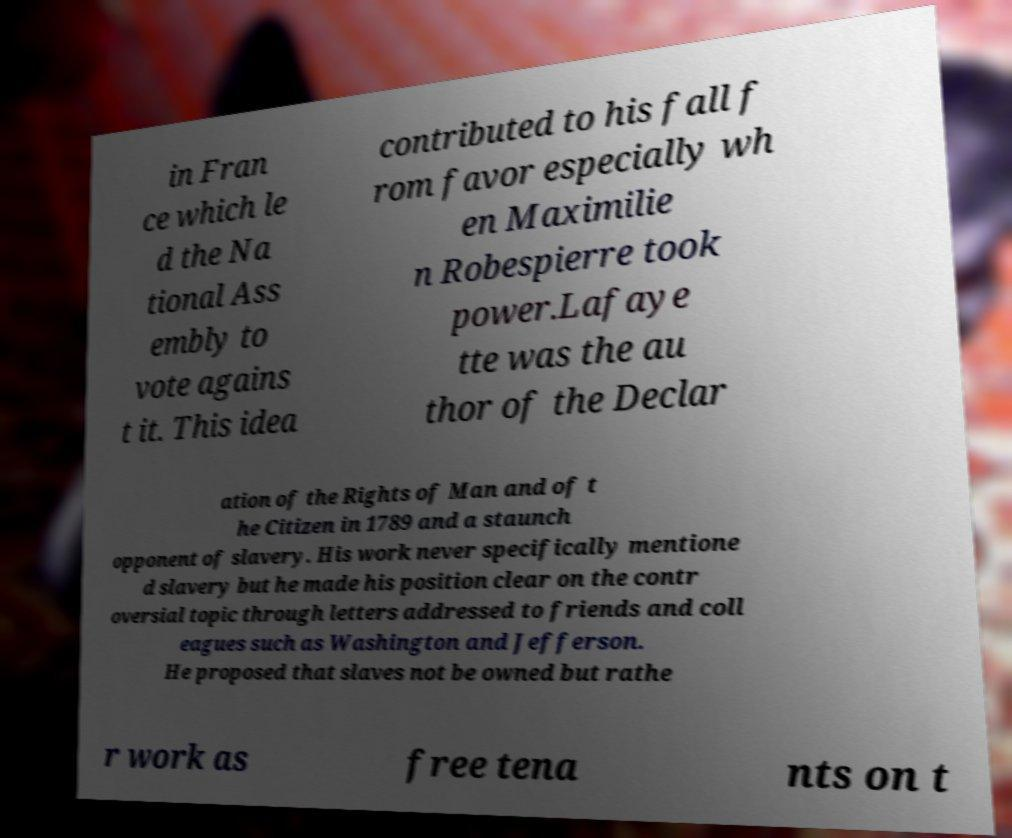For documentation purposes, I need the text within this image transcribed. Could you provide that? in Fran ce which le d the Na tional Ass embly to vote agains t it. This idea contributed to his fall f rom favor especially wh en Maximilie n Robespierre took power.Lafaye tte was the au thor of the Declar ation of the Rights of Man and of t he Citizen in 1789 and a staunch opponent of slavery. His work never specifically mentione d slavery but he made his position clear on the contr oversial topic through letters addressed to friends and coll eagues such as Washington and Jefferson. He proposed that slaves not be owned but rathe r work as free tena nts on t 